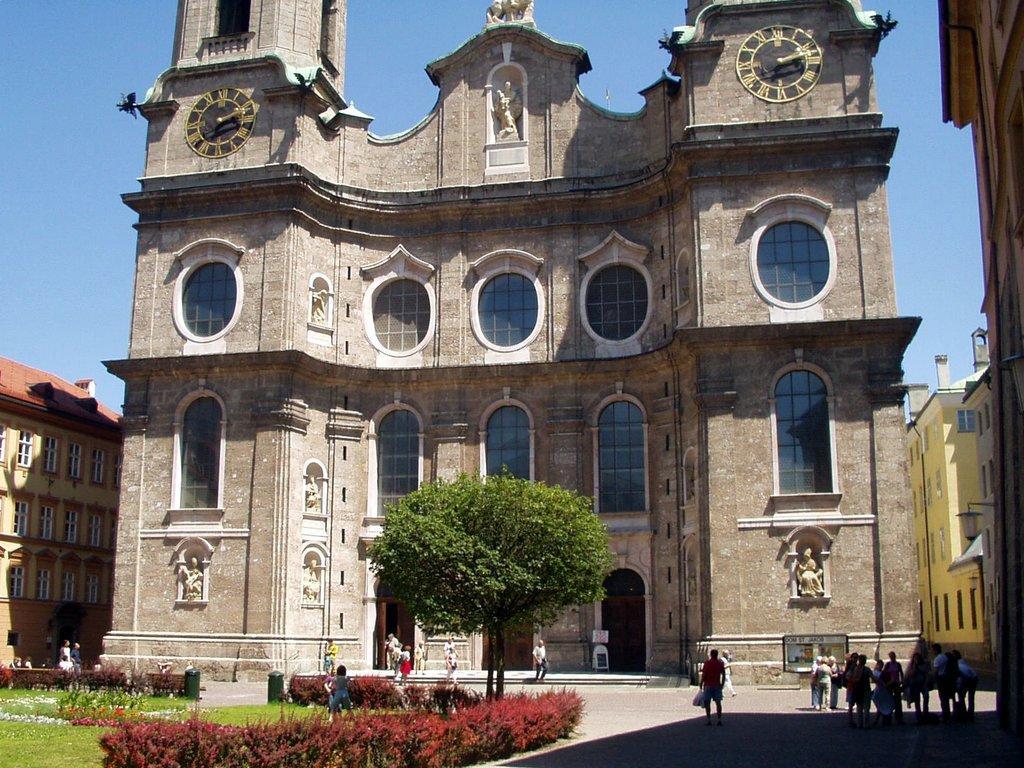Please provide a concise description of this image. In this image, we can see buildings, walls, glass windows, tree, people, plants and grass. At the bottom of the image, there is a walkway. Here we can see stairs, sculpture and clocks. In the background, there is the sky. 